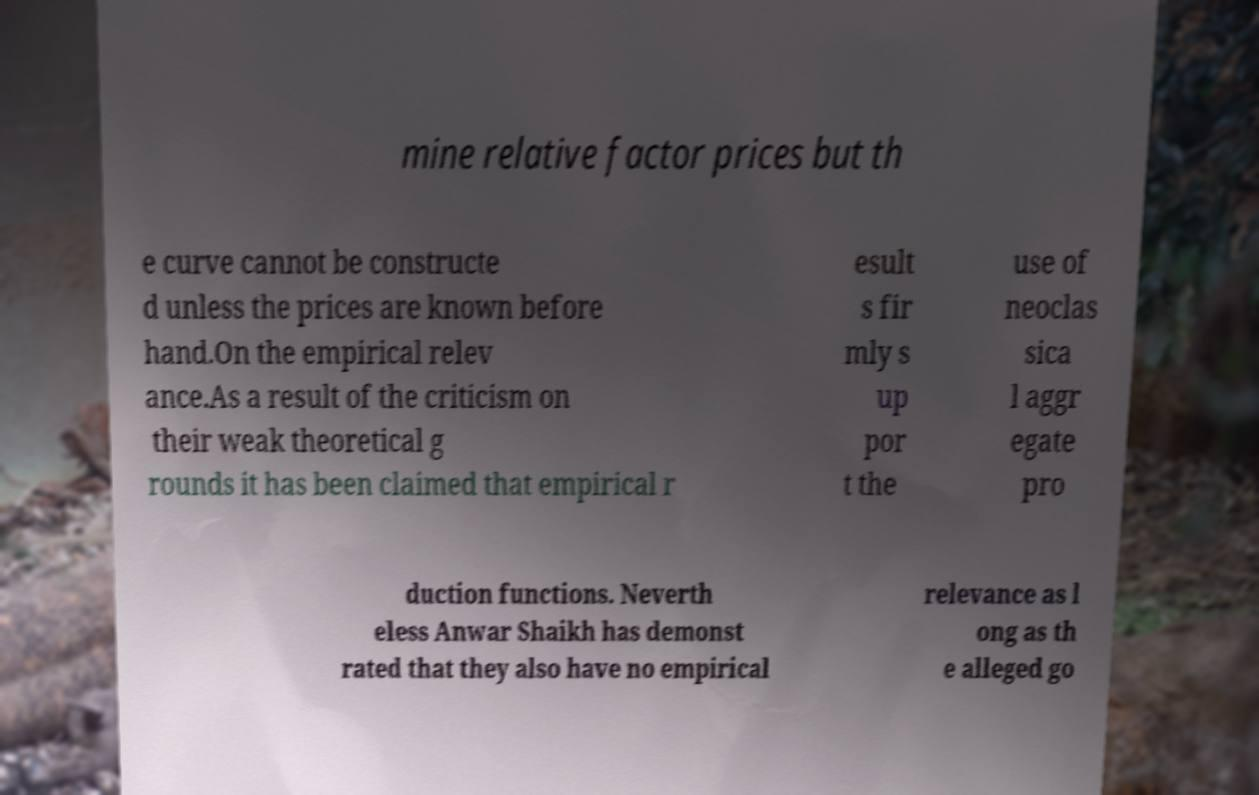Can you accurately transcribe the text from the provided image for me? mine relative factor prices but th e curve cannot be constructe d unless the prices are known before hand.On the empirical relev ance.As a result of the criticism on their weak theoretical g rounds it has been claimed that empirical r esult s fir mly s up por t the use of neoclas sica l aggr egate pro duction functions. Neverth eless Anwar Shaikh has demonst rated that they also have no empirical relevance as l ong as th e alleged go 